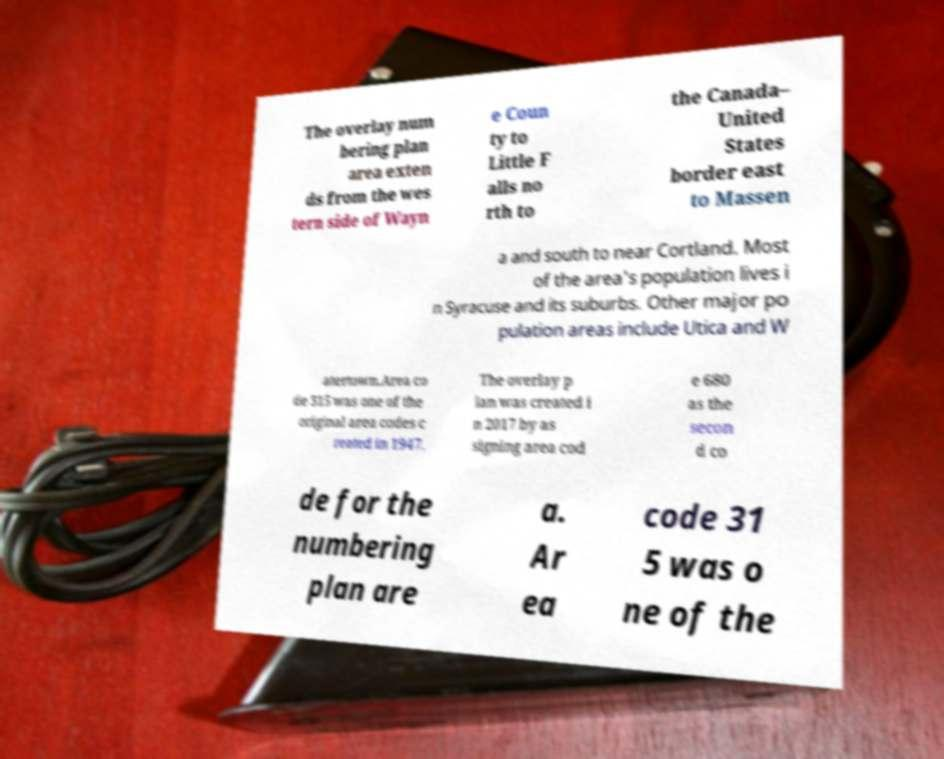For documentation purposes, I need the text within this image transcribed. Could you provide that? The overlay num bering plan area exten ds from the wes tern side of Wayn e Coun ty to Little F alls no rth to the Canada– United States border east to Massen a and south to near Cortland. Most of the area's population lives i n Syracuse and its suburbs. Other major po pulation areas include Utica and W atertown.Area co de 315 was one of the original area codes c reated in 1947. The overlay p lan was created i n 2017 by as signing area cod e 680 as the secon d co de for the numbering plan are a. Ar ea code 31 5 was o ne of the 